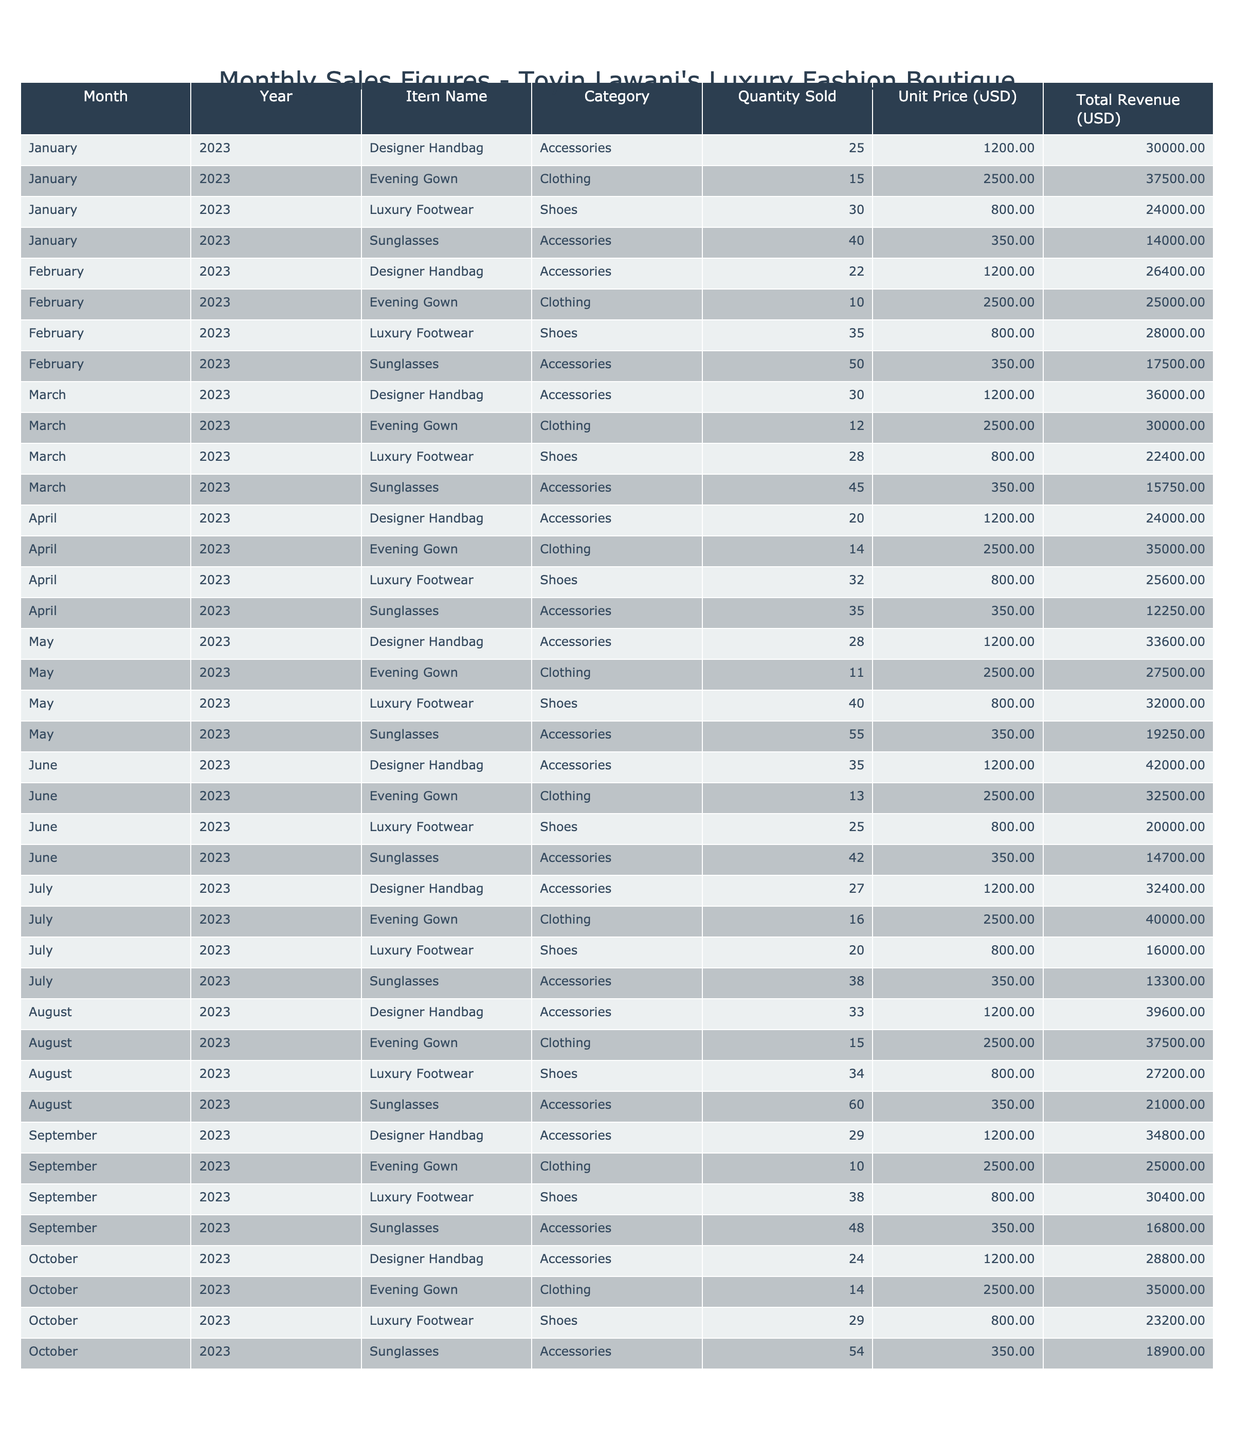What was the total revenue from luxury footwear sales in March 2023? In March 2023, the total revenue from luxury footwear is listed as 22400 USD.
Answer: 22400 USD How many designer handbags were sold in August 2023? According to the table, 33 designer handbags were sold in August 2023.
Answer: 33 What is the average unit price of evening gowns sold in the boutique? The unit price of evening gowns is consistently 2500 USD across all months, thus the average is also 2500 USD.
Answer: 2500 USD Which month had the highest sales of sunglasses? Review each month's total revenue from sunglasses: January (14000), February (17500), March (15750), April (12250), May (19250), June (14700), July (13300), August (21000), September (16800), October (18900). August had the highest sales at 21000 USD.
Answer: August What is the total quantity sold of designer handbags from January to October 2023? Adding the quantities sold each month: 25 (Jan) + 22 (Feb) + 30 (Mar) + 20 (Apr) + 28 (May) + 35 (Jun) + 27 (Jul) + 33 (Aug) + 29 (Sep) + 24 (Oct) gives a total of  25 + 22 + 30 + 20 + 28 + 35 + 27 + 33 + 29 + 24 =  4.
Answer: 4 Did the total revenue from evening gowns exceed 40000 USD in any month? The total revenue for evening gowns is recorded as 37500 (Jan), 25000 (Feb), 30000 (Mar), 35000 (Apr), 27500 (May), 32500 (Jun), 40000 (Jul), 37500 (Aug), and 25000 (Sep). The highest is 40000 USD in July, but did not exceed it.
Answer: No What was the revenue difference between sunglasses and evening gowns in July 2023? From the table, sunglasses revenue in July is 13300 USD and evening gowns revenue is 40000 USD. The difference is 40000 - 13300 = 26700 USD.
Answer: 26700 USD Which luxury item category had the lowest quantity sold in June 2023? Reviewing June's quantities: Designer Handbag (35), Evening Gown (13), Luxury Footwear (25), and Sunglasses (42). Evening gown has the lowest quantity sold with 13 items.
Answer: Evening Gown What is the median total revenue of all categories combined for the month of April 2023? The revenues for April are: 24000 (Handbag), 35000 (Evening Gown), 25600 (Footwear), 12250 (Sunglasses) totaling 24000, 35000, 25600, and 12250. Arranging these we get: 12250, 24000, 25600, 35000. The median is the average of the two middle values: (24000 + 25600) / 2 = 24800.
Answer: 24800 Was there a month where the revenue from luxury footwear was lower than 20000 USD? Checking the footwear revenue over the months: January (24000), February (28000), March (22400), April (25600), May (32000), June (20000), July (16000), August (27200), September (30400), October (23200). The revenue dropped below 20000 USD in July.
Answer: Yes How many more sunglasses were sold in May compared to July? In May, 55 sunglasses were sold, and in July, 38 were sold. The difference is 55 - 38 = 17 sunglasses.
Answer: 17 